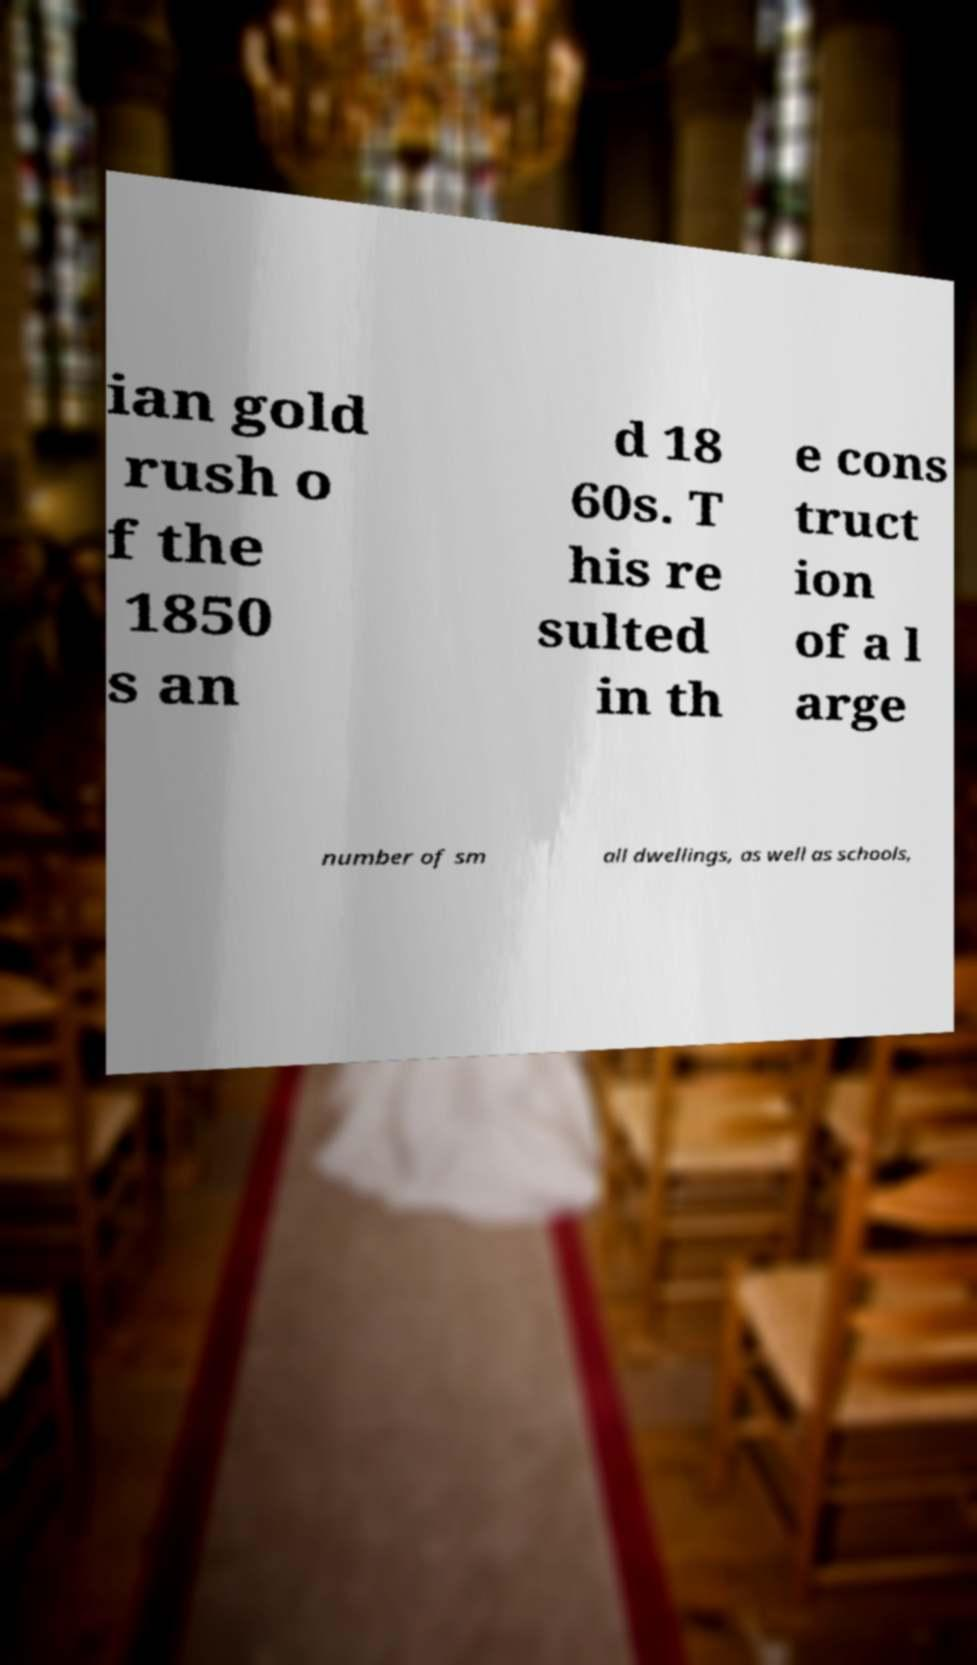Could you assist in decoding the text presented in this image and type it out clearly? ian gold rush o f the 1850 s an d 18 60s. T his re sulted in th e cons truct ion of a l arge number of sm all dwellings, as well as schools, 